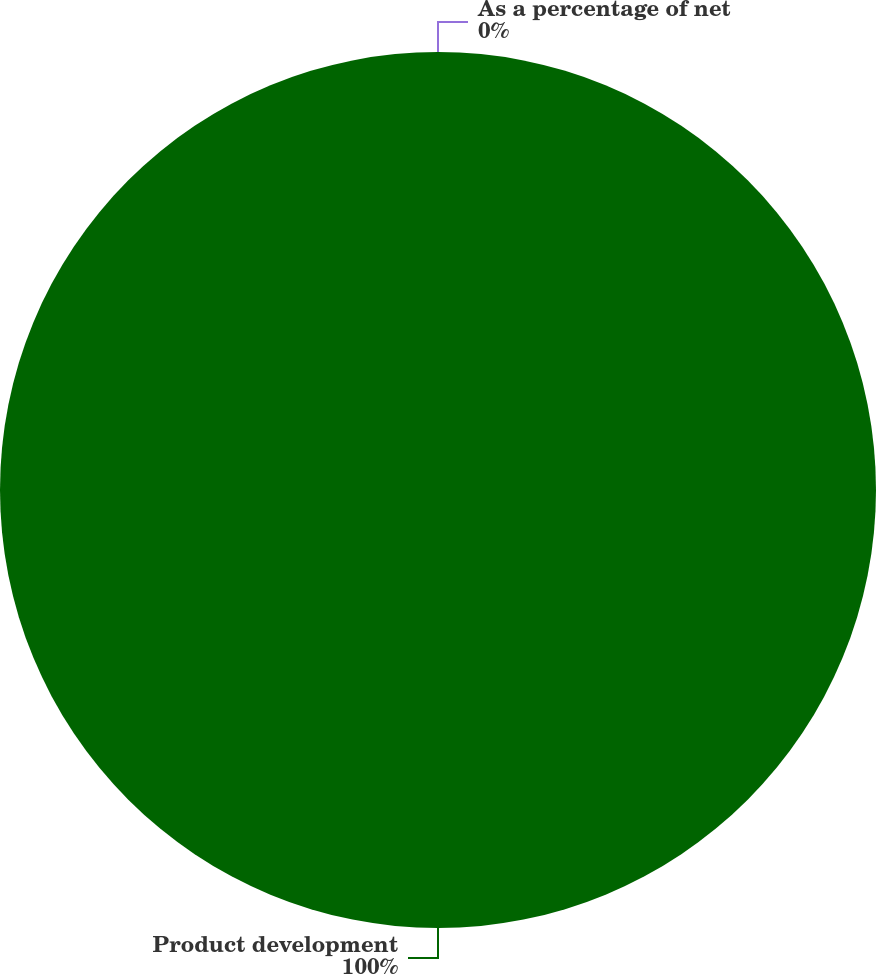<chart> <loc_0><loc_0><loc_500><loc_500><pie_chart><fcel>Product development<fcel>As a percentage of net<nl><fcel>100.0%<fcel>0.0%<nl></chart> 